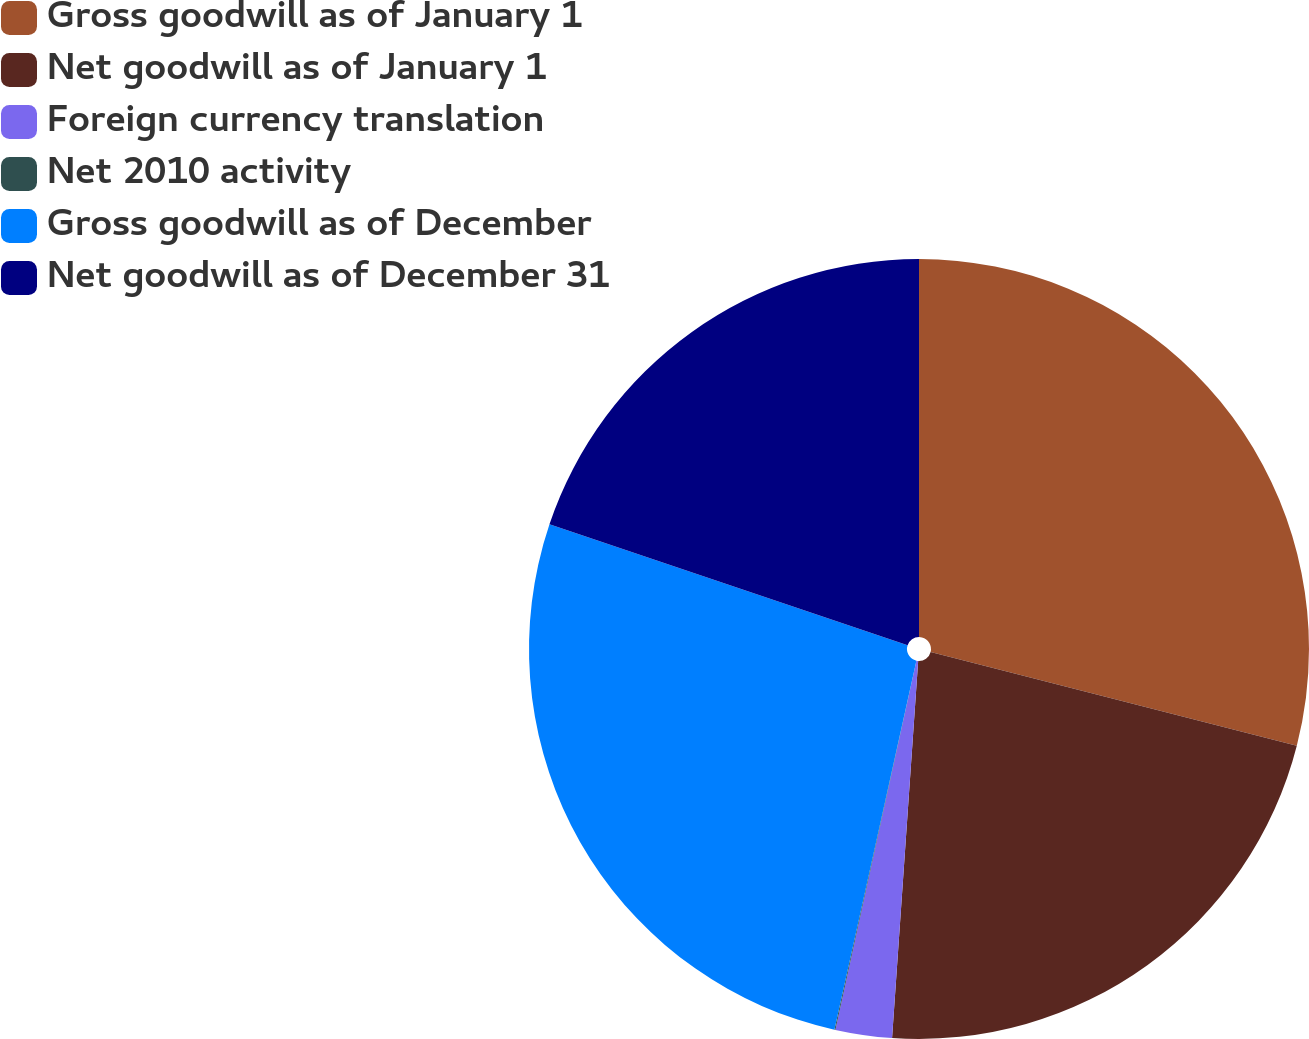Convert chart to OTSL. <chart><loc_0><loc_0><loc_500><loc_500><pie_chart><fcel>Gross goodwill as of January 1<fcel>Net goodwill as of January 1<fcel>Foreign currency translation<fcel>Net 2010 activity<fcel>Gross goodwill as of December<fcel>Net goodwill as of December 31<nl><fcel>28.99%<fcel>22.11%<fcel>2.34%<fcel>0.04%<fcel>26.7%<fcel>19.82%<nl></chart> 